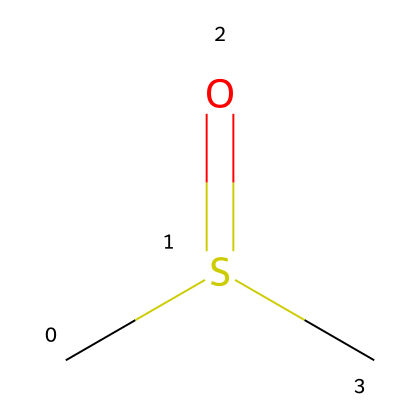What is the molecular formula of this compound? The SMILES representation indicates the presence of 2 carbon atoms (C), 6 hydrogen atoms (H), and 1 sulfur atom (S), as well as 1 oxygen atom (O). Thus, combining them gives the molecular formula C2H6OS.
Answer: C2H6OS How many hydrogen atoms are in dimethyl sulfoxide? By analyzing the SMILES representation, it shows 6 hydrogen (H) atoms directly attached to the carbon atoms in the structure.
Answer: 6 What type of functional group is present in DMSO? The structure shows a sulfur atom double-bonded to an oxygen atom (S=O), which signifies the presence of a sulfoxide functional group.
Answer: sulfoxide What is the total number of bonds present in this molecule? In the molecular structure, there are 2 carbon-carbon bonds, 6 carbon-hydrogen bonds, 1 sulfur-oxygen double bond, and 1 sulfur-carbon bond. Therefore, the total count is 2 + 6 + 1 + 1 = 10 bonds.
Answer: 10 What property does the sulfur atom confer to DMSO? The presence of the sulfur atom in DMSO enables it to act as a polar aprotic solvent, which is useful in various chemical reactions and processes.
Answer: polar aprotic solvent How many distinct elements are present in the structure? The structure contains four distinct elements: carbon (C), hydrogen (H), sulfur (S), and oxygen (O), which can be counted from the molecular representation.
Answer: 4 What is the primary use of dimethyl sulfoxide? DMSO is primarily used as a solvent in various applications, particularly for cleaning electronic circuit boards due to its ability to dissolve a wide range of polar and non-polar compounds.
Answer: solvent 